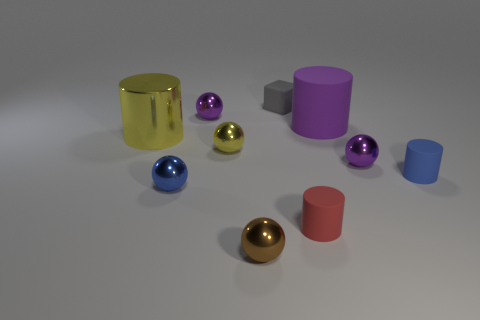Subtract all purple cylinders. How many cylinders are left? 3 Subtract all blocks. How many objects are left? 9 Subtract 1 cubes. How many cubes are left? 0 Subtract all purple spheres. How many spheres are left? 3 Subtract 1 purple cylinders. How many objects are left? 9 Subtract all gray cylinders. Subtract all cyan balls. How many cylinders are left? 4 Subtract all cyan cylinders. How many purple spheres are left? 2 Subtract all tiny brown shiny things. Subtract all large red rubber balls. How many objects are left? 9 Add 1 tiny cylinders. How many tiny cylinders are left? 3 Add 1 metal balls. How many metal balls exist? 6 